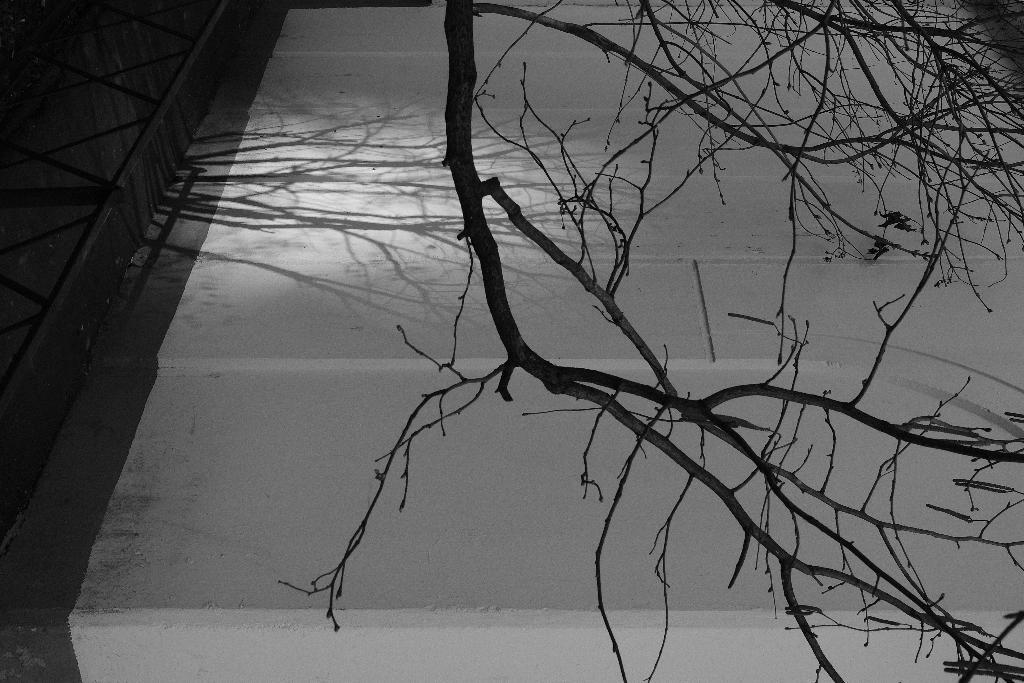Where was the picture taken? The picture was clicked outside. What can be seen on the right side of the image? There are stems and branches of a tree on the right side of the image. What is located on the left side of the image? There is an object on the left side of the image. What is visible in the background of the image? The ground is visible in the background of the image. What type of stocking is hanging from the tree in the image? There is no stocking hanging from the tree in the image; it only features stems and branches of a tree. What musical instrument is being played in the image? There is no musical instrument being played in the image. 